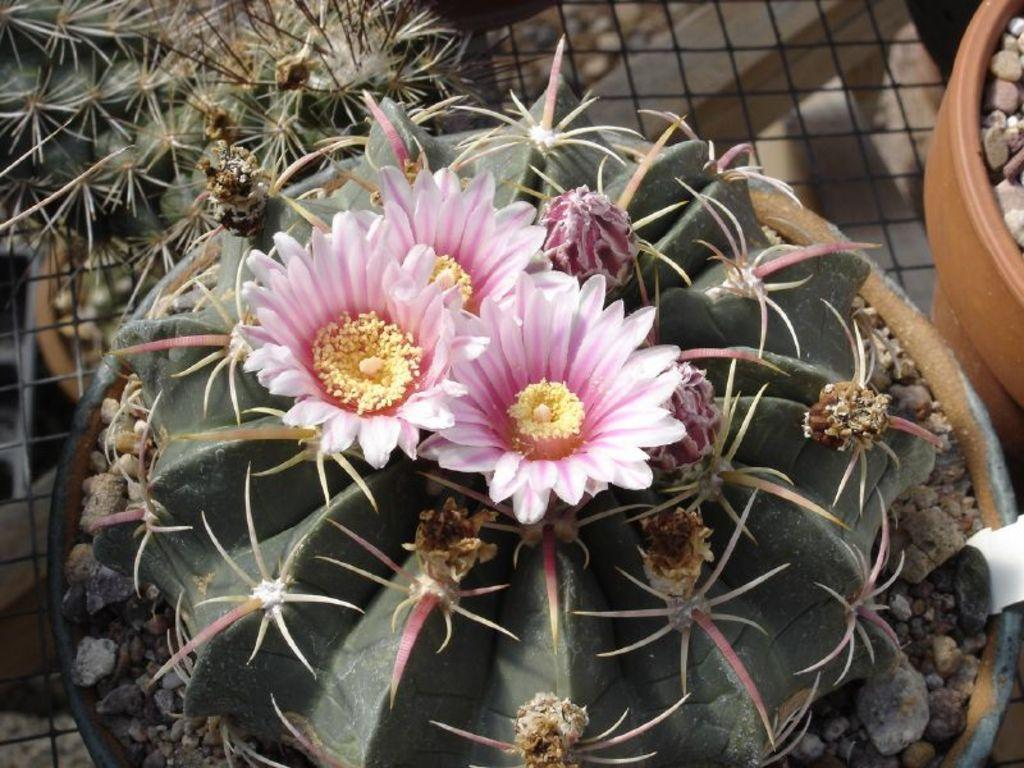What type of plants can be seen in the image? There are pot plants in the image. What other objects are present in the image? There are rocks and flowers in the image. Can you describe the mesh in the image? Yes, there is a mesh in the image. What type of scarecrow can be seen in the image? There is no scarecrow present in the image. How many trains are visible in the image? There are no trains visible in the image. 